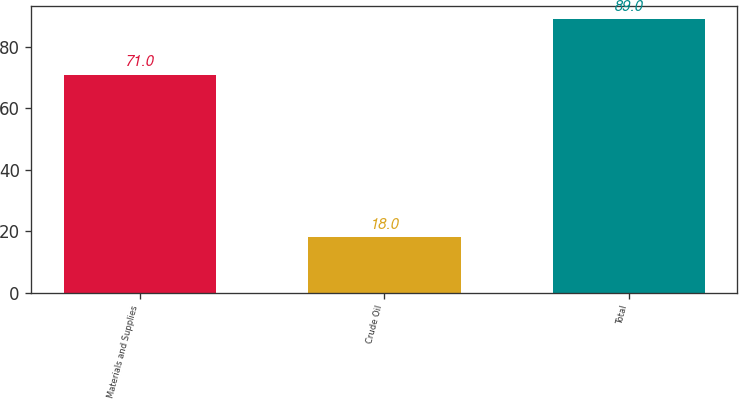Convert chart to OTSL. <chart><loc_0><loc_0><loc_500><loc_500><bar_chart><fcel>Materials and Supplies<fcel>Crude Oil<fcel>Total<nl><fcel>71<fcel>18<fcel>89<nl></chart> 